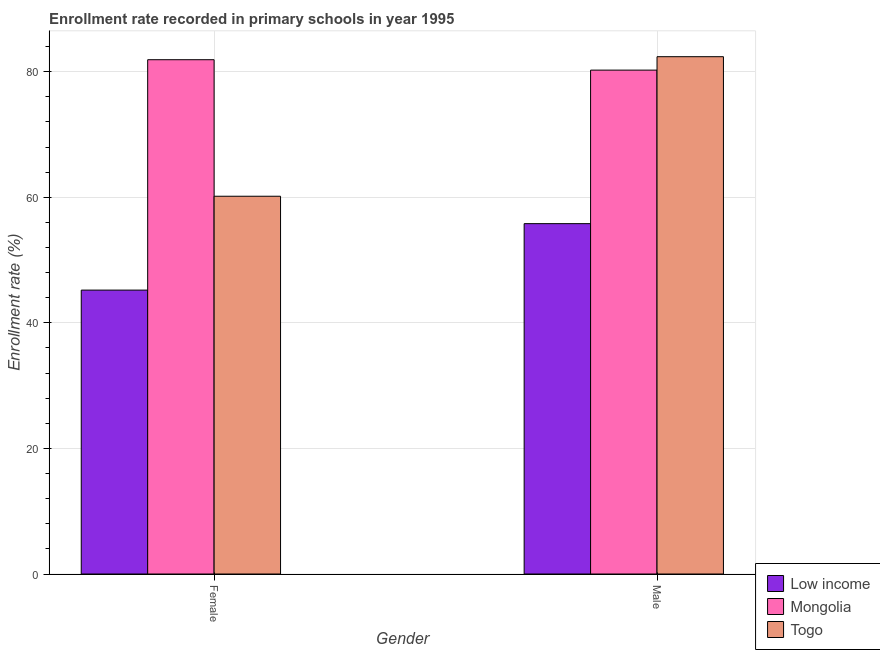Are the number of bars on each tick of the X-axis equal?
Provide a succinct answer. Yes. What is the label of the 2nd group of bars from the left?
Your answer should be very brief. Male. What is the enrollment rate of female students in Mongolia?
Offer a terse response. 81.91. Across all countries, what is the maximum enrollment rate of male students?
Your answer should be compact. 82.39. Across all countries, what is the minimum enrollment rate of male students?
Your response must be concise. 55.8. In which country was the enrollment rate of female students maximum?
Make the answer very short. Mongolia. In which country was the enrollment rate of male students minimum?
Offer a terse response. Low income. What is the total enrollment rate of female students in the graph?
Offer a very short reply. 187.29. What is the difference between the enrollment rate of male students in Togo and that in Mongolia?
Offer a terse response. 2.14. What is the difference between the enrollment rate of male students in Low income and the enrollment rate of female students in Togo?
Provide a succinct answer. -4.36. What is the average enrollment rate of male students per country?
Provide a short and direct response. 72.81. What is the difference between the enrollment rate of male students and enrollment rate of female students in Mongolia?
Provide a short and direct response. -1.66. In how many countries, is the enrollment rate of female students greater than 48 %?
Your response must be concise. 2. What is the ratio of the enrollment rate of male students in Togo to that in Low income?
Your answer should be very brief. 1.48. In how many countries, is the enrollment rate of male students greater than the average enrollment rate of male students taken over all countries?
Keep it short and to the point. 2. What does the 2nd bar from the left in Female represents?
Offer a terse response. Mongolia. What does the 1st bar from the right in Female represents?
Give a very brief answer. Togo. How many bars are there?
Provide a succinct answer. 6. Are all the bars in the graph horizontal?
Your answer should be compact. No. Are the values on the major ticks of Y-axis written in scientific E-notation?
Keep it short and to the point. No. Does the graph contain any zero values?
Your response must be concise. No. What is the title of the graph?
Your answer should be very brief. Enrollment rate recorded in primary schools in year 1995. Does "Bahrain" appear as one of the legend labels in the graph?
Ensure brevity in your answer.  No. What is the label or title of the X-axis?
Your response must be concise. Gender. What is the label or title of the Y-axis?
Give a very brief answer. Enrollment rate (%). What is the Enrollment rate (%) of Low income in Female?
Make the answer very short. 45.21. What is the Enrollment rate (%) in Mongolia in Female?
Make the answer very short. 81.91. What is the Enrollment rate (%) of Togo in Female?
Give a very brief answer. 60.16. What is the Enrollment rate (%) in Low income in Male?
Make the answer very short. 55.8. What is the Enrollment rate (%) in Mongolia in Male?
Ensure brevity in your answer.  80.25. What is the Enrollment rate (%) in Togo in Male?
Make the answer very short. 82.39. Across all Gender, what is the maximum Enrollment rate (%) in Low income?
Your response must be concise. 55.8. Across all Gender, what is the maximum Enrollment rate (%) in Mongolia?
Ensure brevity in your answer.  81.91. Across all Gender, what is the maximum Enrollment rate (%) of Togo?
Offer a very short reply. 82.39. Across all Gender, what is the minimum Enrollment rate (%) of Low income?
Offer a very short reply. 45.21. Across all Gender, what is the minimum Enrollment rate (%) in Mongolia?
Offer a terse response. 80.25. Across all Gender, what is the minimum Enrollment rate (%) in Togo?
Provide a succinct answer. 60.16. What is the total Enrollment rate (%) in Low income in the graph?
Keep it short and to the point. 101.01. What is the total Enrollment rate (%) of Mongolia in the graph?
Provide a short and direct response. 162.16. What is the total Enrollment rate (%) in Togo in the graph?
Give a very brief answer. 142.55. What is the difference between the Enrollment rate (%) of Low income in Female and that in Male?
Provide a short and direct response. -10.58. What is the difference between the Enrollment rate (%) of Mongolia in Female and that in Male?
Offer a very short reply. 1.66. What is the difference between the Enrollment rate (%) in Togo in Female and that in Male?
Your answer should be very brief. -22.23. What is the difference between the Enrollment rate (%) of Low income in Female and the Enrollment rate (%) of Mongolia in Male?
Provide a short and direct response. -35.04. What is the difference between the Enrollment rate (%) in Low income in Female and the Enrollment rate (%) in Togo in Male?
Provide a short and direct response. -37.18. What is the difference between the Enrollment rate (%) in Mongolia in Female and the Enrollment rate (%) in Togo in Male?
Your answer should be very brief. -0.48. What is the average Enrollment rate (%) in Low income per Gender?
Provide a short and direct response. 50.51. What is the average Enrollment rate (%) in Mongolia per Gender?
Provide a succinct answer. 81.08. What is the average Enrollment rate (%) in Togo per Gender?
Offer a terse response. 71.28. What is the difference between the Enrollment rate (%) in Low income and Enrollment rate (%) in Mongolia in Female?
Provide a succinct answer. -36.69. What is the difference between the Enrollment rate (%) of Low income and Enrollment rate (%) of Togo in Female?
Your answer should be compact. -14.95. What is the difference between the Enrollment rate (%) of Mongolia and Enrollment rate (%) of Togo in Female?
Provide a short and direct response. 21.74. What is the difference between the Enrollment rate (%) of Low income and Enrollment rate (%) of Mongolia in Male?
Offer a very short reply. -24.45. What is the difference between the Enrollment rate (%) of Low income and Enrollment rate (%) of Togo in Male?
Make the answer very short. -26.59. What is the difference between the Enrollment rate (%) in Mongolia and Enrollment rate (%) in Togo in Male?
Offer a terse response. -2.14. What is the ratio of the Enrollment rate (%) of Low income in Female to that in Male?
Provide a succinct answer. 0.81. What is the ratio of the Enrollment rate (%) of Mongolia in Female to that in Male?
Offer a terse response. 1.02. What is the ratio of the Enrollment rate (%) of Togo in Female to that in Male?
Your answer should be compact. 0.73. What is the difference between the highest and the second highest Enrollment rate (%) of Low income?
Make the answer very short. 10.58. What is the difference between the highest and the second highest Enrollment rate (%) of Mongolia?
Make the answer very short. 1.66. What is the difference between the highest and the second highest Enrollment rate (%) in Togo?
Your answer should be very brief. 22.23. What is the difference between the highest and the lowest Enrollment rate (%) in Low income?
Ensure brevity in your answer.  10.58. What is the difference between the highest and the lowest Enrollment rate (%) in Mongolia?
Your answer should be compact. 1.66. What is the difference between the highest and the lowest Enrollment rate (%) in Togo?
Ensure brevity in your answer.  22.23. 